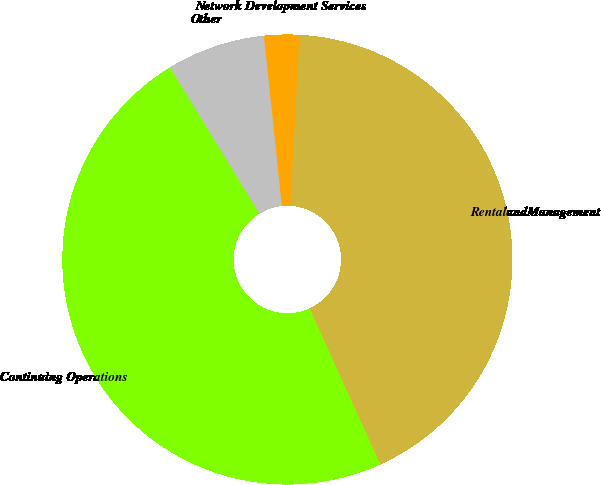Convert chart to OTSL. <chart><loc_0><loc_0><loc_500><loc_500><pie_chart><fcel>RentalandManagement<fcel>Network Development Services<fcel>Other<fcel>Continuing Operations<nl><fcel>42.38%<fcel>2.52%<fcel>7.07%<fcel>48.03%<nl></chart> 